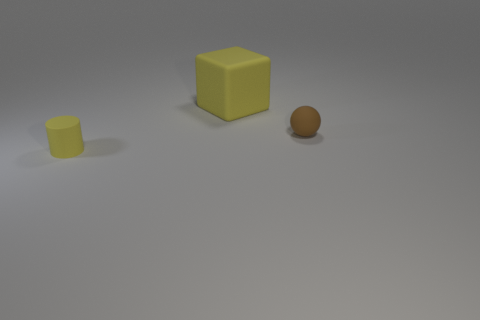Add 3 matte cylinders. How many objects exist? 6 Subtract all cubes. How many objects are left? 2 Subtract all cylinders. Subtract all cubes. How many objects are left? 1 Add 1 big objects. How many big objects are left? 2 Add 3 big yellow rubber things. How many big yellow rubber things exist? 4 Subtract 0 gray balls. How many objects are left? 3 